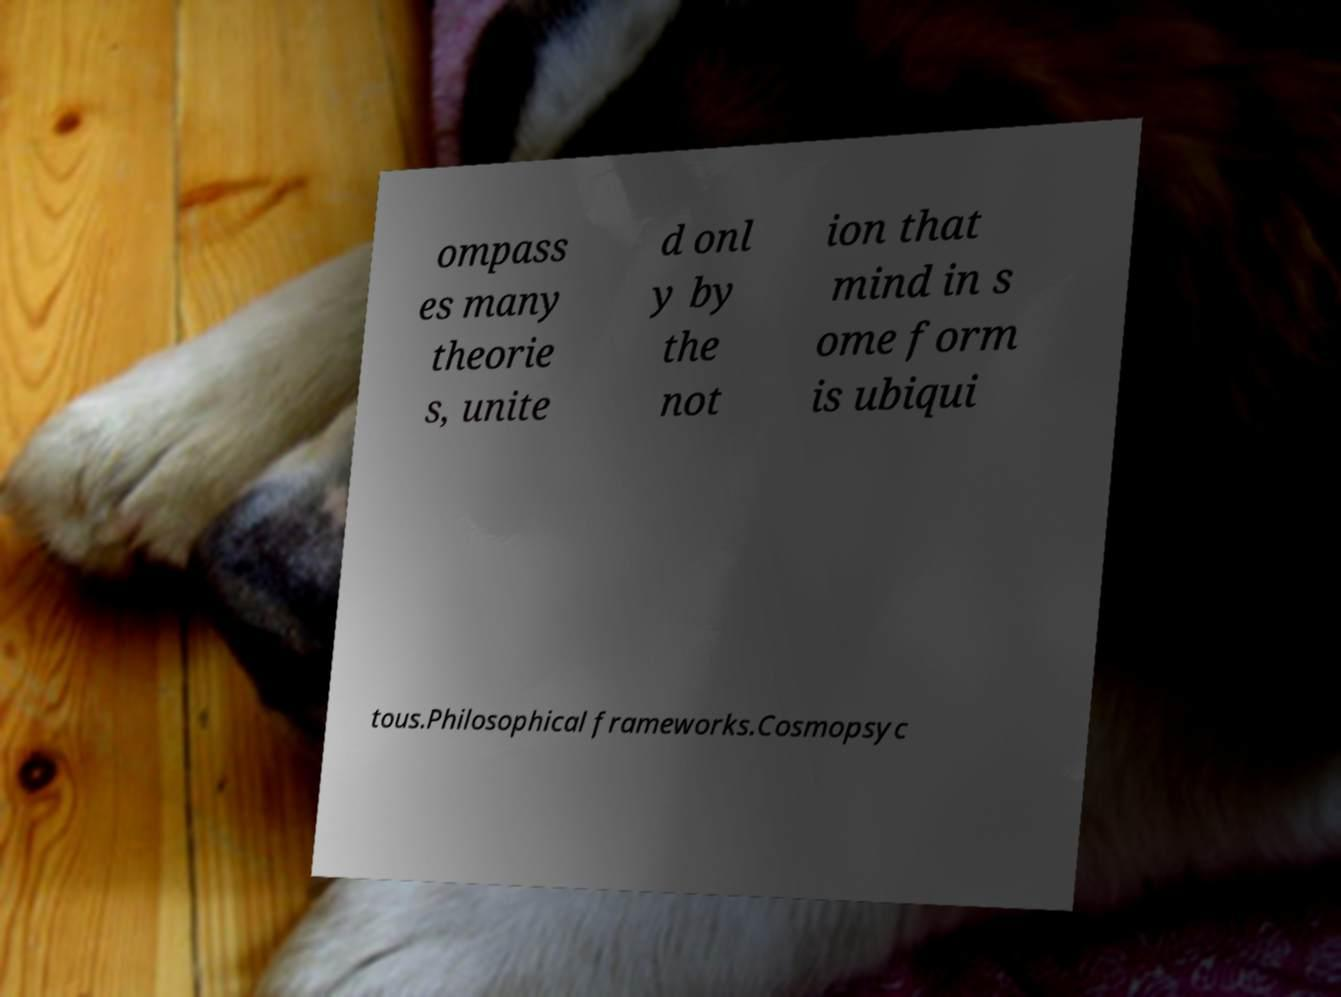Can you accurately transcribe the text from the provided image for me? ompass es many theorie s, unite d onl y by the not ion that mind in s ome form is ubiqui tous.Philosophical frameworks.Cosmopsyc 